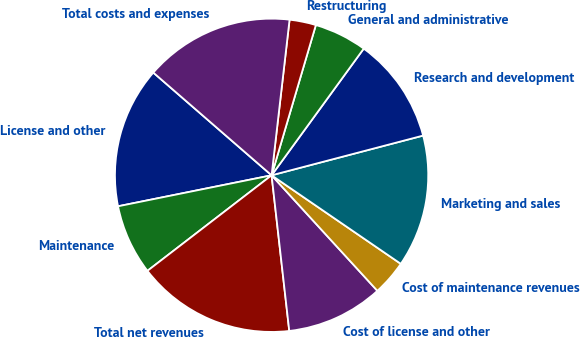<chart> <loc_0><loc_0><loc_500><loc_500><pie_chart><fcel>License and other<fcel>Maintenance<fcel>Total net revenues<fcel>Cost of license and other<fcel>Cost of maintenance revenues<fcel>Marketing and sales<fcel>Research and development<fcel>General and administrative<fcel>Restructuring<fcel>Total costs and expenses<nl><fcel>14.55%<fcel>7.27%<fcel>16.36%<fcel>10.0%<fcel>3.64%<fcel>13.64%<fcel>10.91%<fcel>5.45%<fcel>2.73%<fcel>15.45%<nl></chart> 